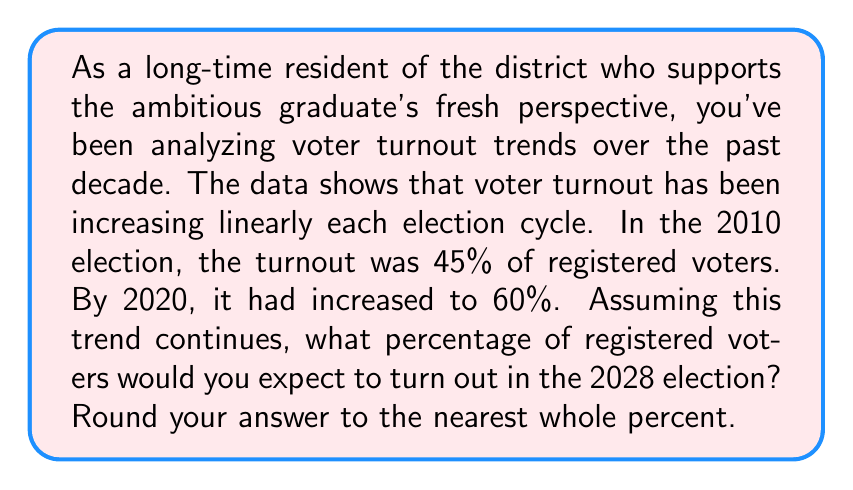Could you help me with this problem? Let's approach this step-by-step:

1) First, we need to calculate the rate of increase per election cycle.

2) We know that from 2010 to 2020 (which is 3 election cycles as they occur every 4 years), the turnout increased from 45% to 60%.

3) Total increase: $60\% - 45\% = 15\%$

4) Increase per election cycle: $\frac{15\%}{3} = 5\%$

5) Now, we need to determine how many election cycles will occur between 2020 and 2028.
   2024 is 1 cycle after 2020
   2028 is 2 cycles after 2020

6) So, we expect two more increases of 5% each after the 2020 turnout of 60%.

7) Expected turnout in 2028: $60\% + (2 \times 5\%) = 60\% + 10\% = 70\%$

Therefore, based on the linear trend, we would expect a 70% voter turnout in 2028.
Answer: 70% 